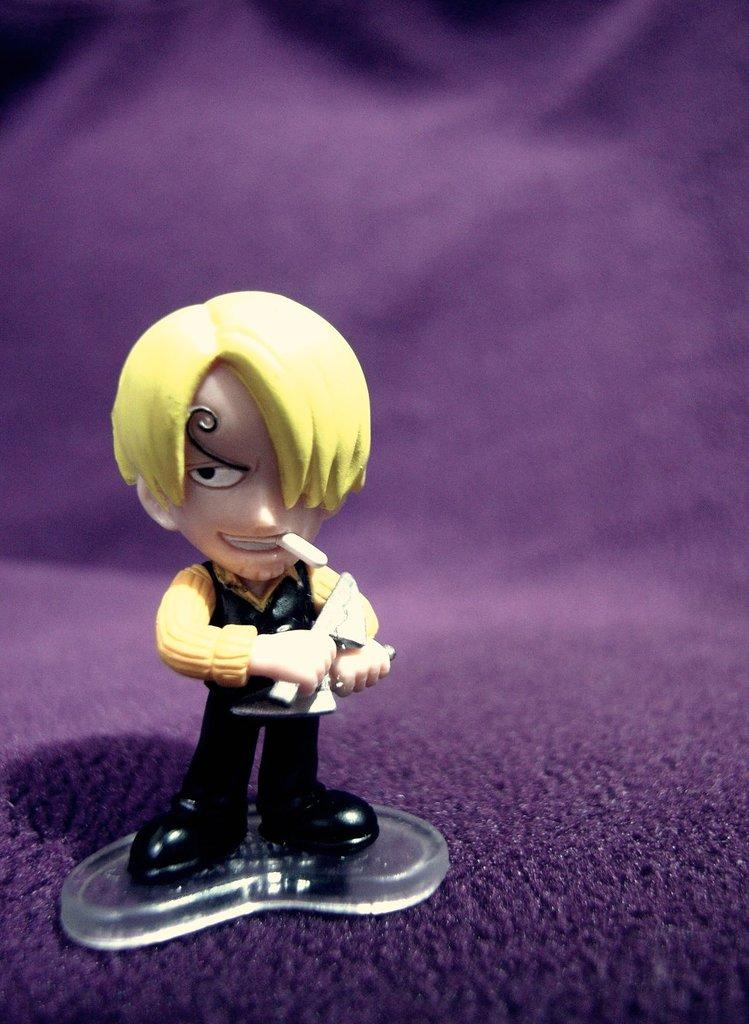What is the main object in the image? There is a toy in the image. Can you describe the colors of the toy? The toy has yellow, cream, and black colors. What color is the background of the image? The background of the image is in purple color. Is there a plastic alarm in the front of the image? There is no plastic alarm present in the image. 